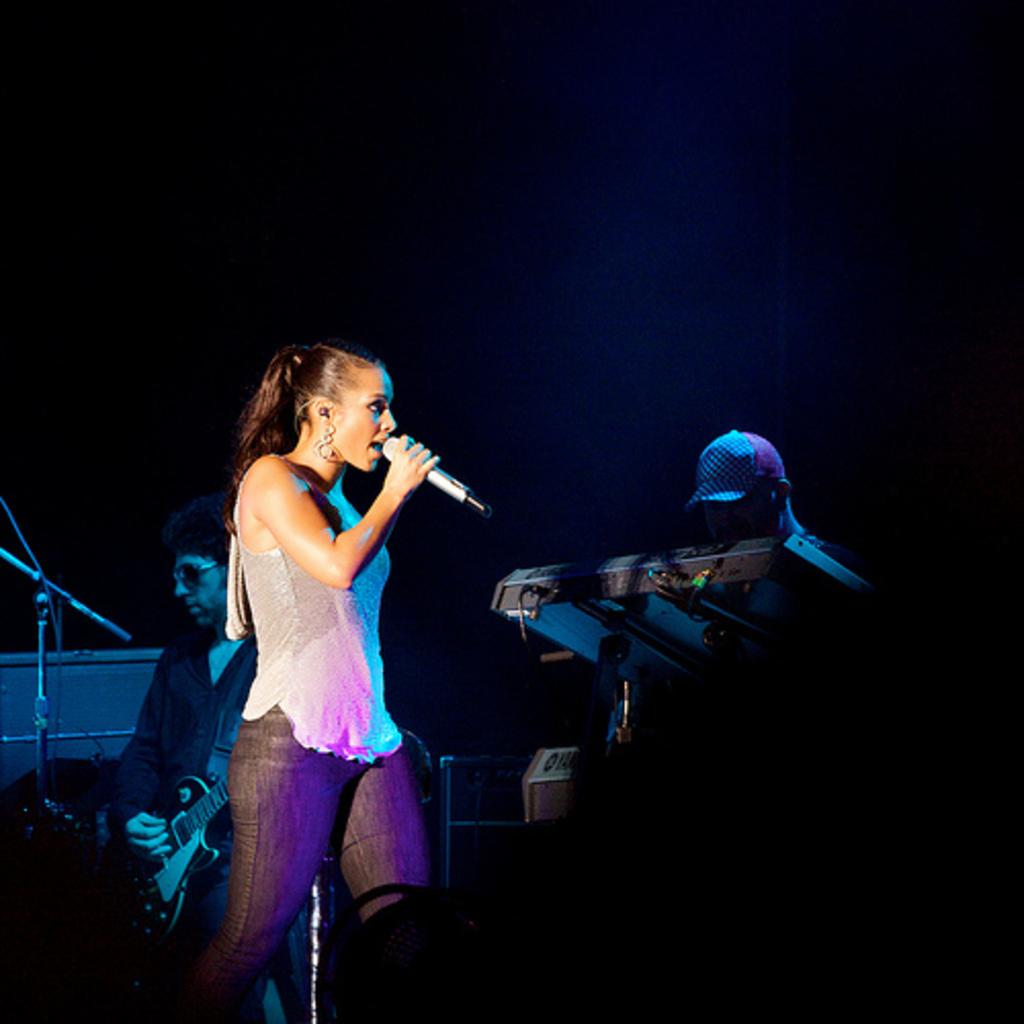What is the person in the image doing? The person is standing in the image and holding a mic. Are there any other people in the image? Yes, there are two people playing musical instruments in the image. What can be seen in the background of the image? The background of the image is black. Can you see a squirrel holding a kite in the image? No, there is no squirrel or kite present in the image. 